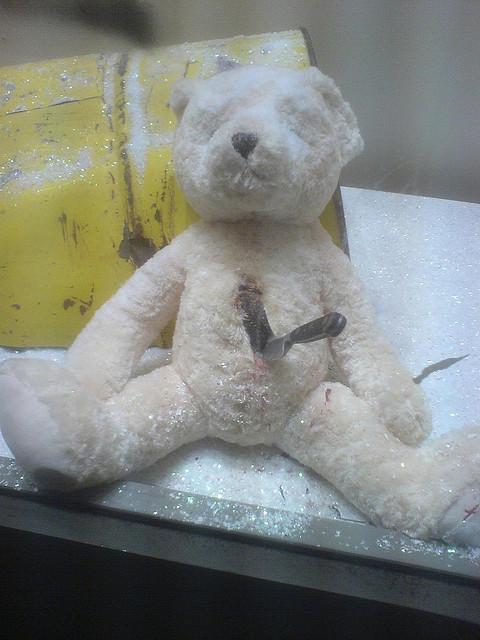What color is the teddy bear?
Be succinct. White. Does the bear have eyes?
Keep it brief. No. Do they have eyes?
Quick response, please. No. Did someone try to kill the teddy bear?
Concise answer only. Yes. 